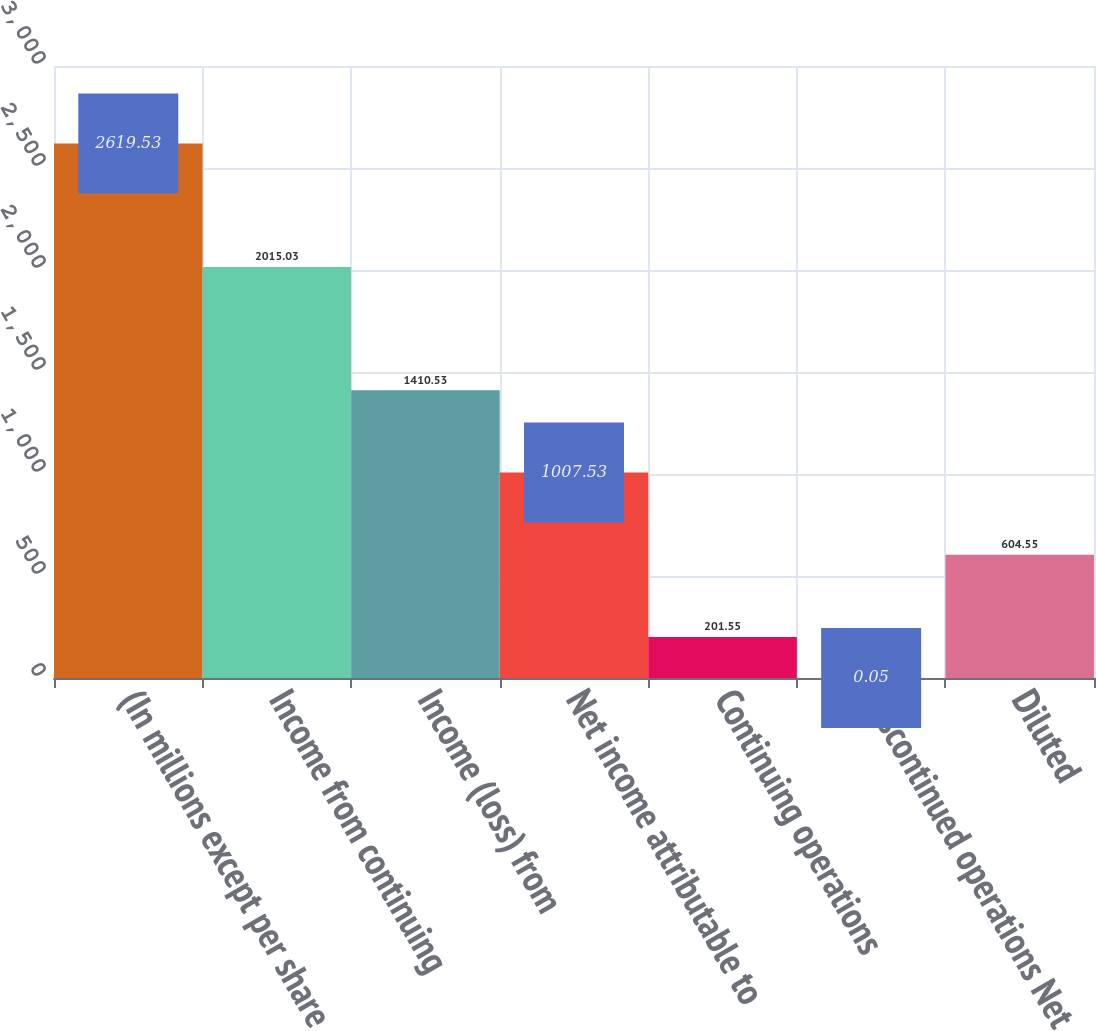<chart> <loc_0><loc_0><loc_500><loc_500><bar_chart><fcel>(In millions except per share<fcel>Income from continuing<fcel>Income (loss) from<fcel>Net income attributable to<fcel>Continuing operations<fcel>Discontinued operations Net<fcel>Diluted<nl><fcel>2619.53<fcel>2015.03<fcel>1410.53<fcel>1007.53<fcel>201.55<fcel>0.05<fcel>604.55<nl></chart> 